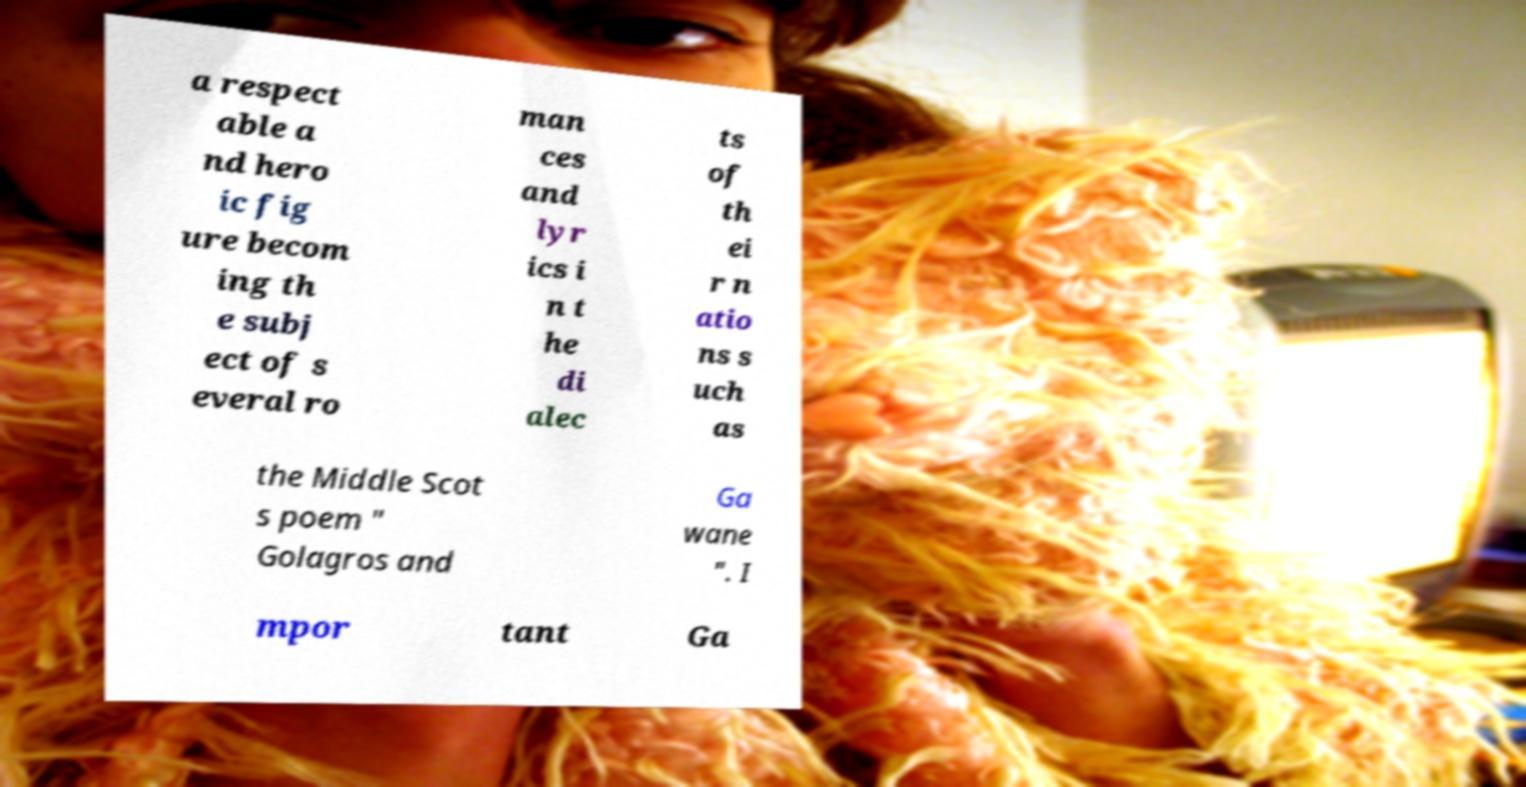There's text embedded in this image that I need extracted. Can you transcribe it verbatim? a respect able a nd hero ic fig ure becom ing th e subj ect of s everal ro man ces and lyr ics i n t he di alec ts of th ei r n atio ns s uch as the Middle Scot s poem " Golagros and Ga wane ". I mpor tant Ga 